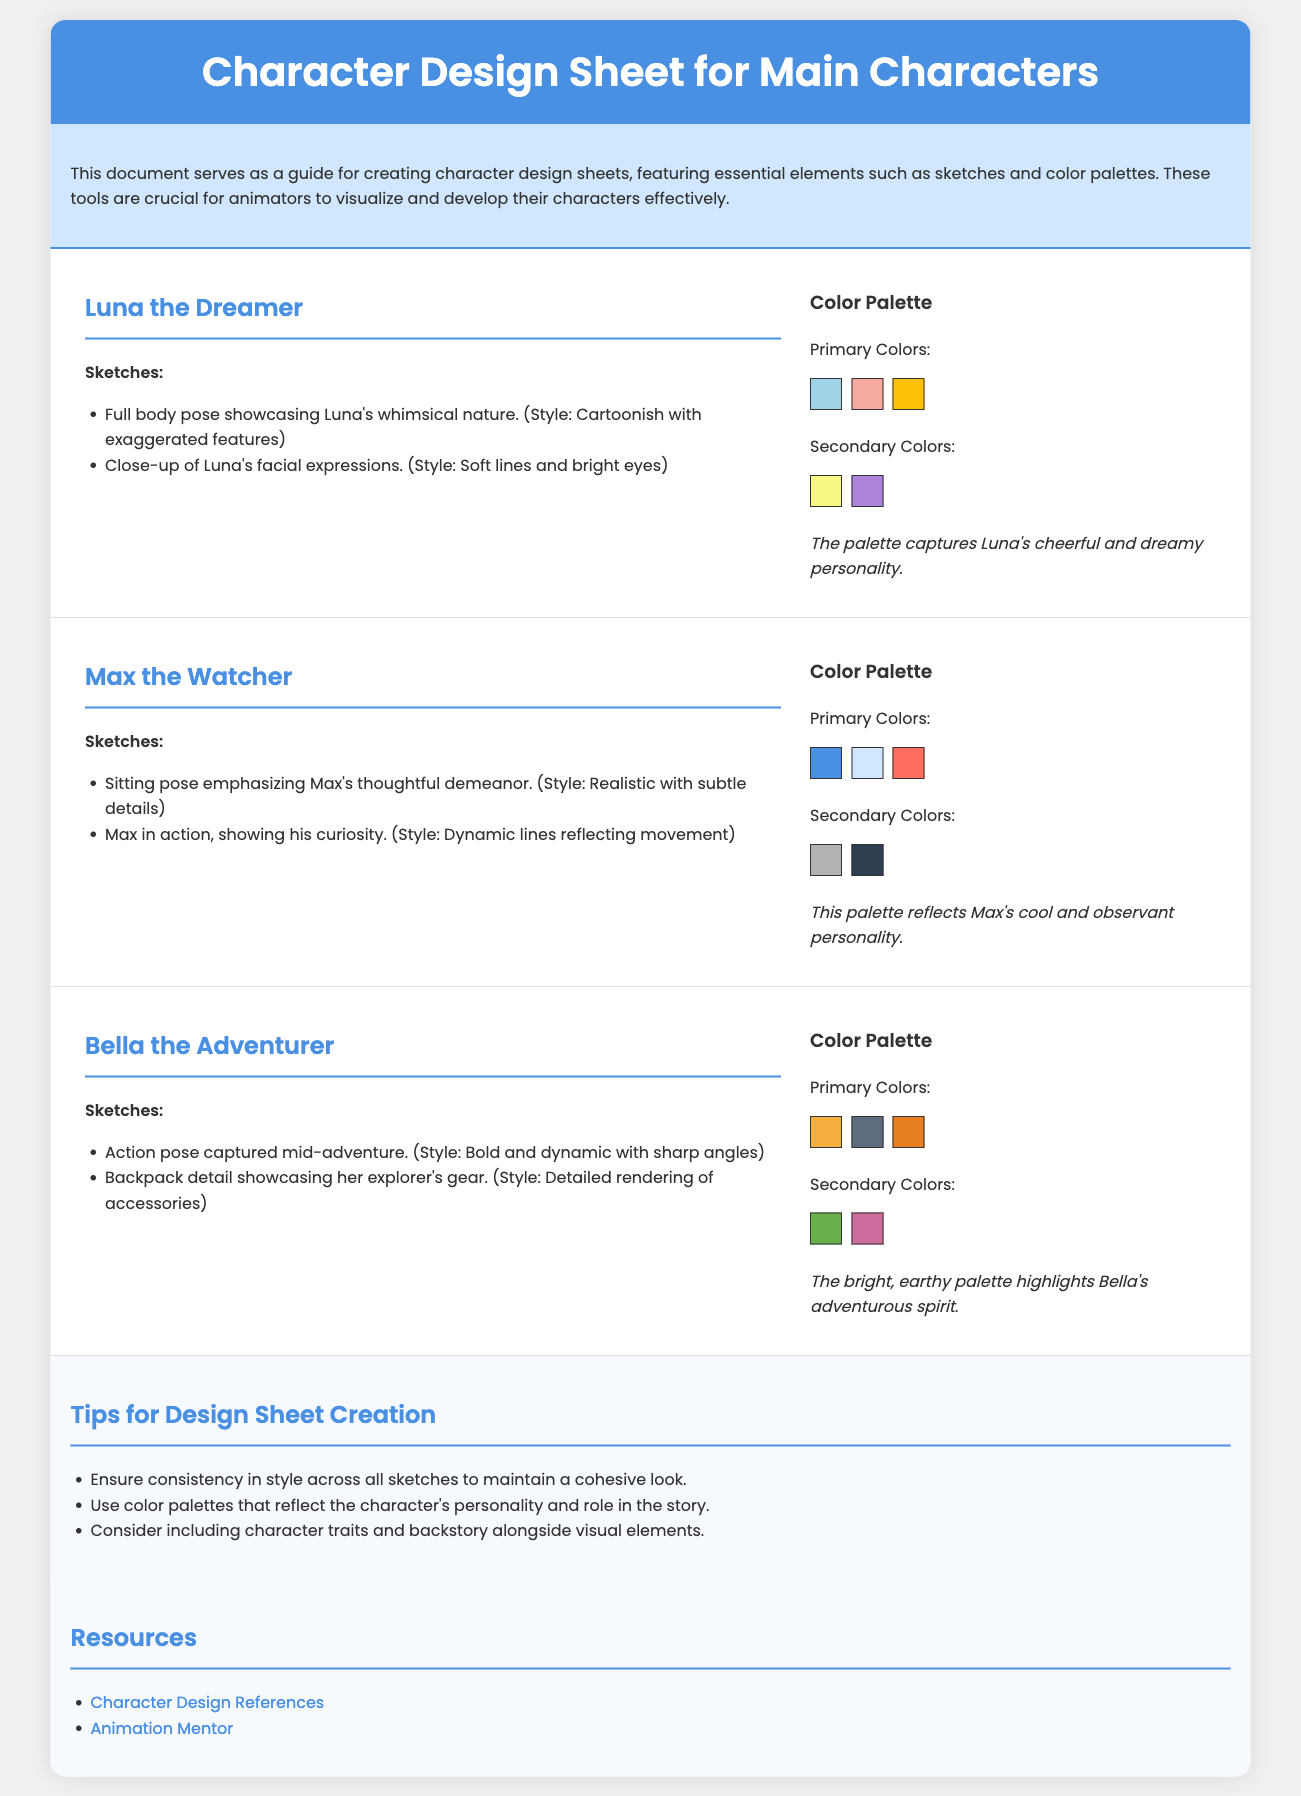What is the name of the first character? The name of the first character is mentioned in the document, and it is "Luna the Dreamer."
Answer: Luna the Dreamer How many primary colors are listed for Max the Watcher? The document specifies that there are three primary colors listed for Max the Watcher.
Answer: 3 What character has a backpack detail in their sketches? The character mentioned as having a backpack detail in their sketches is "Bella the Adventurer."
Answer: Bella the Adventurer What type of style is used for Luna's full body pose? The document describes the style used for Luna's full body pose as "Cartoonish with exaggerated features."
Answer: Cartoonish with exaggerated features Which element is included in the tips for design sheet creation? One of the elements included in the tips is to ensure consistency in style across all sketches.
Answer: Consistency in style How many secondary colors does Bella the Adventurer have? The document indicates that Bella the Adventurer has two secondary colors listed.
Answer: 2 What color palette reflects Max's personality? The color palette that reflects Max's personality includes minor details and is specified as "cool and observant."
Answer: Cool and observant What are the sketches of Luna focused on? The sketches of Luna are focused on full body poses showcasing her nature and close-ups of her facial expressions.
Answer: Full body poses and close-ups Which resource is provided for character design references? The specific resource mentioned for character design references in the document is a website link.
Answer: Character Design References 